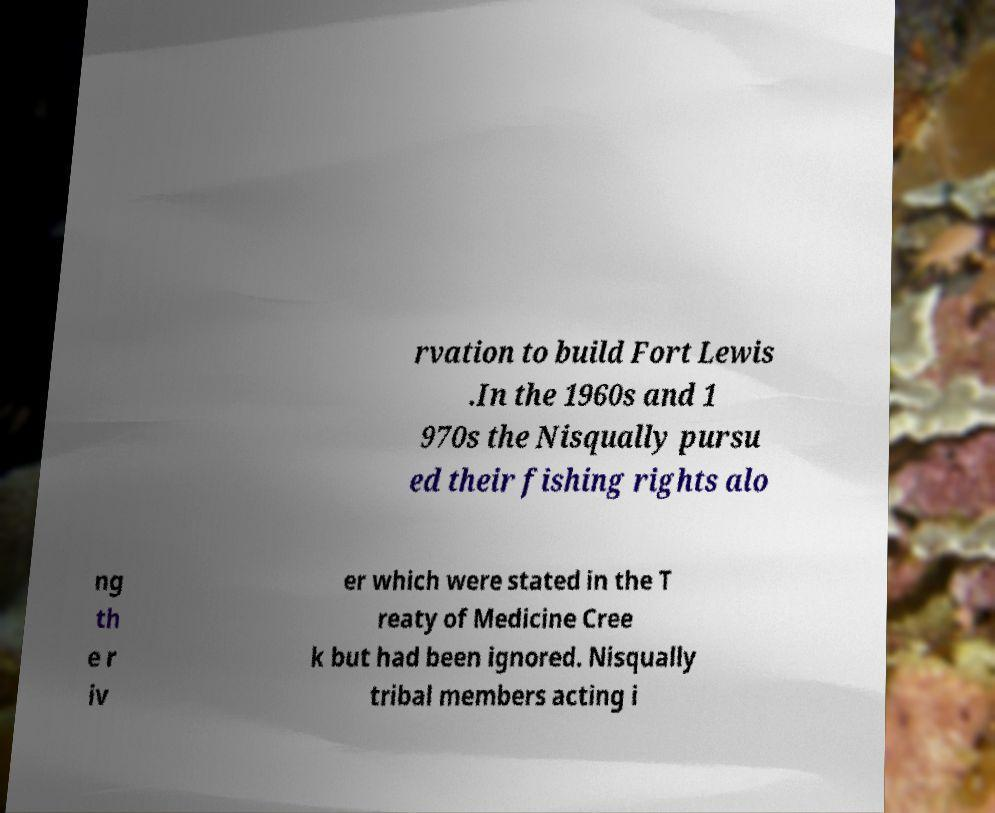What messages or text are displayed in this image? I need them in a readable, typed format. rvation to build Fort Lewis .In the 1960s and 1 970s the Nisqually pursu ed their fishing rights alo ng th e r iv er which were stated in the T reaty of Medicine Cree k but had been ignored. Nisqually tribal members acting i 